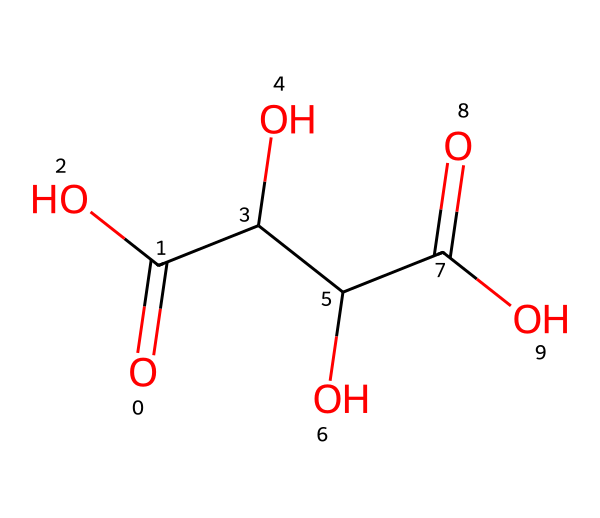What is the molecular formula of tartaric acid? By analyzing the given SMILES representation, we can determine the atoms present. The structure contains two carbonyl (C=O) groups, 4 carbons (C), 6 hydrogens (H), and 4 oxygens (O). Therefore, the molecular formula is C4H6O6.
Answer: C4H6O6 How many hydroxyl (-OH) groups are in tartaric acid? Looking at the SMILES structure, we can identify that there are three hydroxyl (-OH) functional groups indicating the presence of three alcohols within the molecule.
Answer: 3 What functional groups are present in tartaric acid? Examining the structure, we see the presence of carboxylic acids (-COOH) and hydroxyl groups (-OH). Since there are two carbonyls and three hydroxyls visible in the structure, these are the two main functional groups present.
Answer: carboxylic acids and hydroxyl groups How many total rings are present in the structure of tartaric acid? In the SMILES representation, there are no cyclic structures or rings shown as the arrangement is linear. Thus, we conclude that there are no rings present in tartaric acid.
Answer: 0 What type of isomerism can tartaric acid exhibit? Given that tartaric acid can exist in different stereochemical forms (due to its chiral centers), it exhibits optical isomerism. The two enantiomers are mirror images of each other, giving it this property.
Answer: optical isomerism What role does tartaric acid play in winemaking? Tartaric acid is known for its role in stabilizing the wine's pH and contributing to its acidity. This is vital for maintaining the quality and taste of wine during fermentation.
Answer: acidity and pH stabilization 